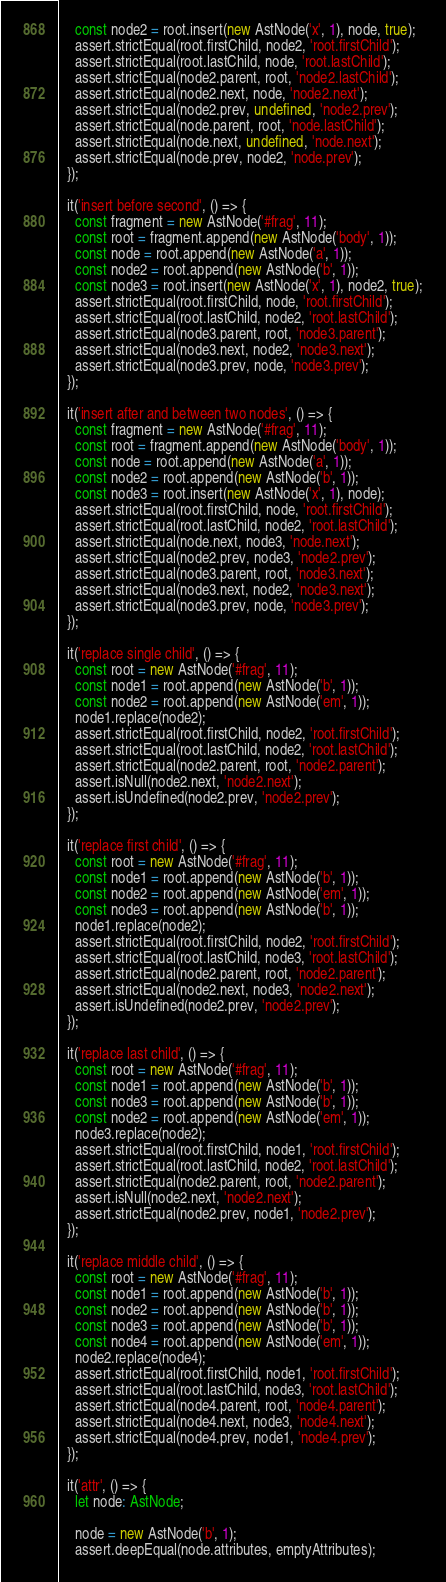<code> <loc_0><loc_0><loc_500><loc_500><_TypeScript_>    const node2 = root.insert(new AstNode('x', 1), node, true);
    assert.strictEqual(root.firstChild, node2, 'root.firstChild');
    assert.strictEqual(root.lastChild, node, 'root.lastChild');
    assert.strictEqual(node2.parent, root, 'node2.lastChild');
    assert.strictEqual(node2.next, node, 'node2.next');
    assert.strictEqual(node2.prev, undefined, 'node2.prev');
    assert.strictEqual(node.parent, root, 'node.lastChild');
    assert.strictEqual(node.next, undefined, 'node.next');
    assert.strictEqual(node.prev, node2, 'node.prev');
  });

  it('insert before second', () => {
    const fragment = new AstNode('#frag', 11);
    const root = fragment.append(new AstNode('body', 1));
    const node = root.append(new AstNode('a', 1));
    const node2 = root.append(new AstNode('b', 1));
    const node3 = root.insert(new AstNode('x', 1), node2, true);
    assert.strictEqual(root.firstChild, node, 'root.firstChild');
    assert.strictEqual(root.lastChild, node2, 'root.lastChild');
    assert.strictEqual(node3.parent, root, 'node3.parent');
    assert.strictEqual(node3.next, node2, 'node3.next');
    assert.strictEqual(node3.prev, node, 'node3.prev');
  });

  it('insert after and between two nodes', () => {
    const fragment = new AstNode('#frag', 11);
    const root = fragment.append(new AstNode('body', 1));
    const node = root.append(new AstNode('a', 1));
    const node2 = root.append(new AstNode('b', 1));
    const node3 = root.insert(new AstNode('x', 1), node);
    assert.strictEqual(root.firstChild, node, 'root.firstChild');
    assert.strictEqual(root.lastChild, node2, 'root.lastChild');
    assert.strictEqual(node.next, node3, 'node.next');
    assert.strictEqual(node2.prev, node3, 'node2.prev');
    assert.strictEqual(node3.parent, root, 'node3.next');
    assert.strictEqual(node3.next, node2, 'node3.next');
    assert.strictEqual(node3.prev, node, 'node3.prev');
  });

  it('replace single child', () => {
    const root = new AstNode('#frag', 11);
    const node1 = root.append(new AstNode('b', 1));
    const node2 = root.append(new AstNode('em', 1));
    node1.replace(node2);
    assert.strictEqual(root.firstChild, node2, 'root.firstChild');
    assert.strictEqual(root.lastChild, node2, 'root.lastChild');
    assert.strictEqual(node2.parent, root, 'node2.parent');
    assert.isNull(node2.next, 'node2.next');
    assert.isUndefined(node2.prev, 'node2.prev');
  });

  it('replace first child', () => {
    const root = new AstNode('#frag', 11);
    const node1 = root.append(new AstNode('b', 1));
    const node2 = root.append(new AstNode('em', 1));
    const node3 = root.append(new AstNode('b', 1));
    node1.replace(node2);
    assert.strictEqual(root.firstChild, node2, 'root.firstChild');
    assert.strictEqual(root.lastChild, node3, 'root.lastChild');
    assert.strictEqual(node2.parent, root, 'node2.parent');
    assert.strictEqual(node2.next, node3, 'node2.next');
    assert.isUndefined(node2.prev, 'node2.prev');
  });

  it('replace last child', () => {
    const root = new AstNode('#frag', 11);
    const node1 = root.append(new AstNode('b', 1));
    const node3 = root.append(new AstNode('b', 1));
    const node2 = root.append(new AstNode('em', 1));
    node3.replace(node2);
    assert.strictEqual(root.firstChild, node1, 'root.firstChild');
    assert.strictEqual(root.lastChild, node2, 'root.lastChild');
    assert.strictEqual(node2.parent, root, 'node2.parent');
    assert.isNull(node2.next, 'node2.next');
    assert.strictEqual(node2.prev, node1, 'node2.prev');
  });

  it('replace middle child', () => {
    const root = new AstNode('#frag', 11);
    const node1 = root.append(new AstNode('b', 1));
    const node2 = root.append(new AstNode('b', 1));
    const node3 = root.append(new AstNode('b', 1));
    const node4 = root.append(new AstNode('em', 1));
    node2.replace(node4);
    assert.strictEqual(root.firstChild, node1, 'root.firstChild');
    assert.strictEqual(root.lastChild, node3, 'root.lastChild');
    assert.strictEqual(node4.parent, root, 'node4.parent');
    assert.strictEqual(node4.next, node3, 'node4.next');
    assert.strictEqual(node4.prev, node1, 'node4.prev');
  });

  it('attr', () => {
    let node: AstNode;

    node = new AstNode('b', 1);
    assert.deepEqual(node.attributes, emptyAttributes);</code> 